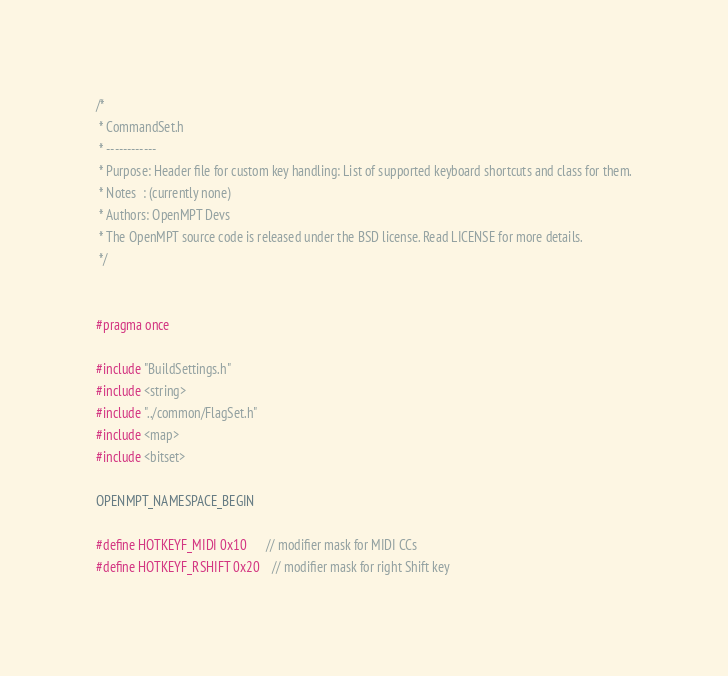<code> <loc_0><loc_0><loc_500><loc_500><_C_>/*
 * CommandSet.h
 * ------------
 * Purpose: Header file for custom key handling: List of supported keyboard shortcuts and class for them.
 * Notes  : (currently none)
 * Authors: OpenMPT Devs
 * The OpenMPT source code is released under the BSD license. Read LICENSE for more details.
 */


#pragma once

#include "BuildSettings.h"
#include <string>
#include "../common/FlagSet.h"
#include <map>
#include <bitset>

OPENMPT_NAMESPACE_BEGIN

#define HOTKEYF_MIDI 0x10      // modifier mask for MIDI CCs
#define HOTKEYF_RSHIFT 0x20    // modifier mask for right Shift key</code> 